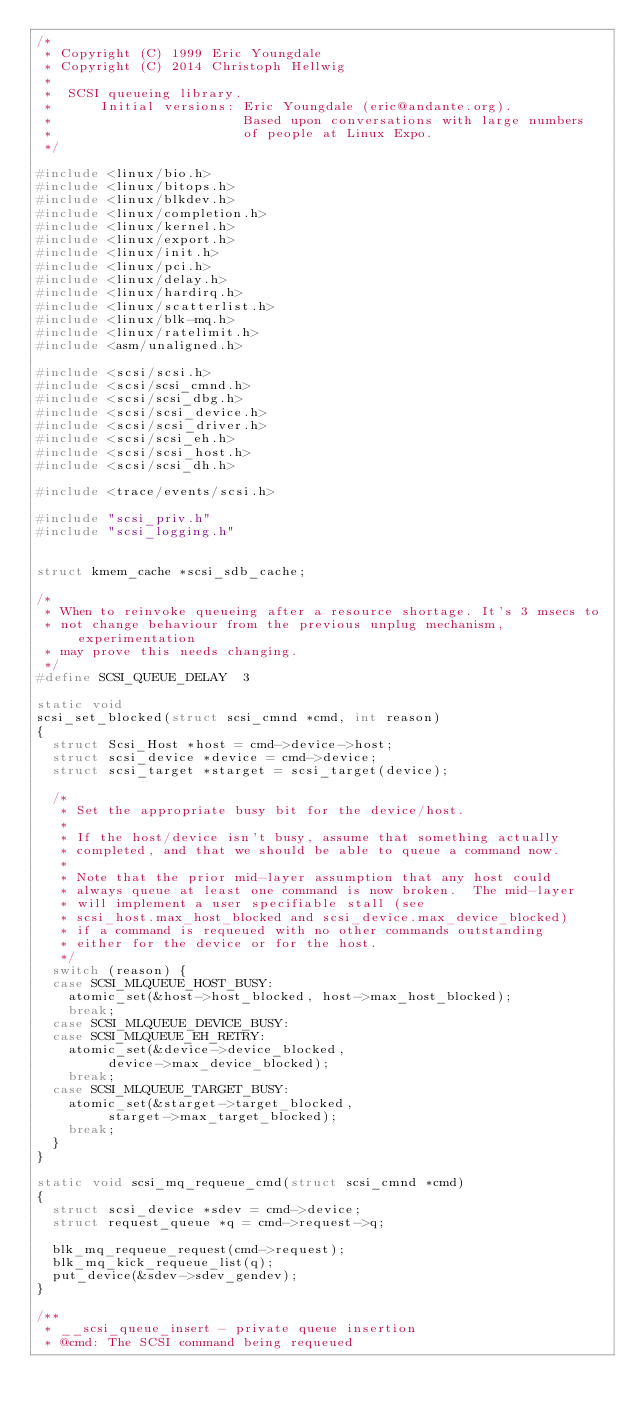Convert code to text. <code><loc_0><loc_0><loc_500><loc_500><_C_>/*
 * Copyright (C) 1999 Eric Youngdale
 * Copyright (C) 2014 Christoph Hellwig
 *
 *  SCSI queueing library.
 *      Initial versions: Eric Youngdale (eric@andante.org).
 *                        Based upon conversations with large numbers
 *                        of people at Linux Expo.
 */

#include <linux/bio.h>
#include <linux/bitops.h>
#include <linux/blkdev.h>
#include <linux/completion.h>
#include <linux/kernel.h>
#include <linux/export.h>
#include <linux/init.h>
#include <linux/pci.h>
#include <linux/delay.h>
#include <linux/hardirq.h>
#include <linux/scatterlist.h>
#include <linux/blk-mq.h>
#include <linux/ratelimit.h>
#include <asm/unaligned.h>

#include <scsi/scsi.h>
#include <scsi/scsi_cmnd.h>
#include <scsi/scsi_dbg.h>
#include <scsi/scsi_device.h>
#include <scsi/scsi_driver.h>
#include <scsi/scsi_eh.h>
#include <scsi/scsi_host.h>
#include <scsi/scsi_dh.h>

#include <trace/events/scsi.h>

#include "scsi_priv.h"
#include "scsi_logging.h"


struct kmem_cache *scsi_sdb_cache;

/*
 * When to reinvoke queueing after a resource shortage. It's 3 msecs to
 * not change behaviour from the previous unplug mechanism, experimentation
 * may prove this needs changing.
 */
#define SCSI_QUEUE_DELAY	3

static void
scsi_set_blocked(struct scsi_cmnd *cmd, int reason)
{
	struct Scsi_Host *host = cmd->device->host;
	struct scsi_device *device = cmd->device;
	struct scsi_target *starget = scsi_target(device);

	/*
	 * Set the appropriate busy bit for the device/host.
	 *
	 * If the host/device isn't busy, assume that something actually
	 * completed, and that we should be able to queue a command now.
	 *
	 * Note that the prior mid-layer assumption that any host could
	 * always queue at least one command is now broken.  The mid-layer
	 * will implement a user specifiable stall (see
	 * scsi_host.max_host_blocked and scsi_device.max_device_blocked)
	 * if a command is requeued with no other commands outstanding
	 * either for the device or for the host.
	 */
	switch (reason) {
	case SCSI_MLQUEUE_HOST_BUSY:
		atomic_set(&host->host_blocked, host->max_host_blocked);
		break;
	case SCSI_MLQUEUE_DEVICE_BUSY:
	case SCSI_MLQUEUE_EH_RETRY:
		atomic_set(&device->device_blocked,
			   device->max_device_blocked);
		break;
	case SCSI_MLQUEUE_TARGET_BUSY:
		atomic_set(&starget->target_blocked,
			   starget->max_target_blocked);
		break;
	}
}

static void scsi_mq_requeue_cmd(struct scsi_cmnd *cmd)
{
	struct scsi_device *sdev = cmd->device;
	struct request_queue *q = cmd->request->q;

	blk_mq_requeue_request(cmd->request);
	blk_mq_kick_requeue_list(q);
	put_device(&sdev->sdev_gendev);
}

/**
 * __scsi_queue_insert - private queue insertion
 * @cmd: The SCSI command being requeued</code> 